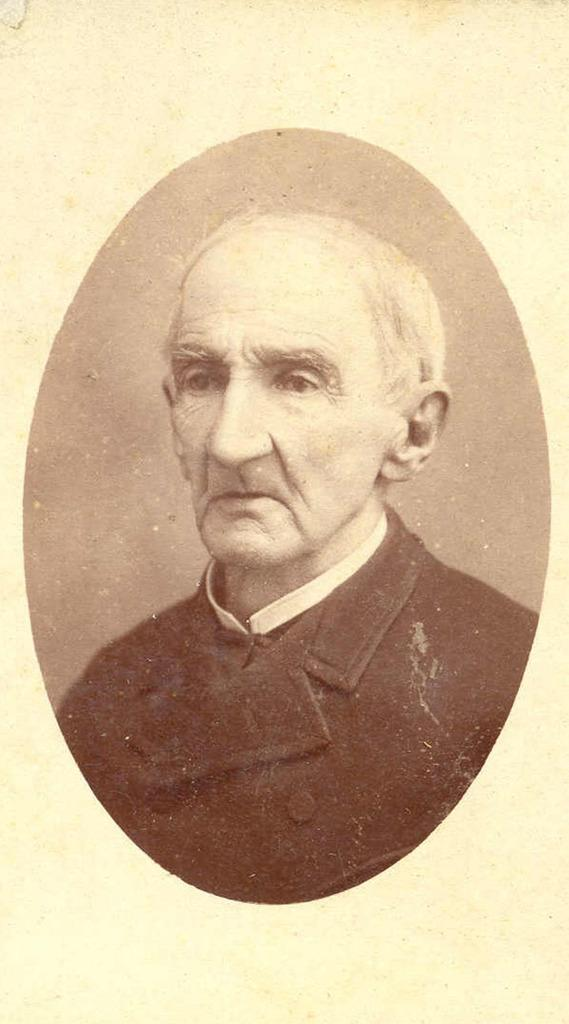What is the main subject of the image? There is a picture of an old man in the image. What type of donkey can be seen in the image? There is no donkey present in the image. 